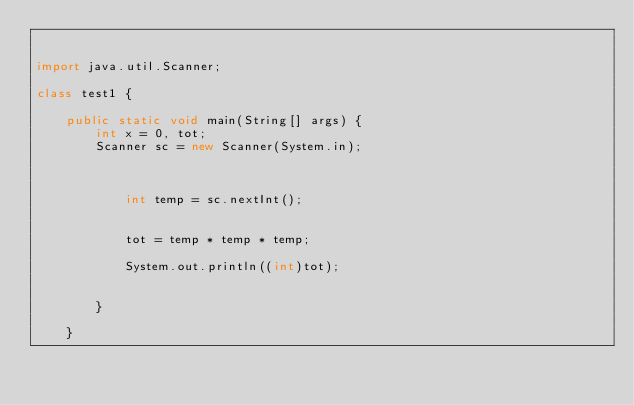Convert code to text. <code><loc_0><loc_0><loc_500><loc_500><_Java_>
 
import java.util.Scanner;
 
class test1 {
 
    public static void main(String[] args) {
        int x = 0, tot;
        Scanner sc = new Scanner(System.in);
 

 
            int temp = sc.nextInt();

 
            tot = temp * temp * temp;
 
            System.out.println((int)tot);

 
        }
 
    }</code> 